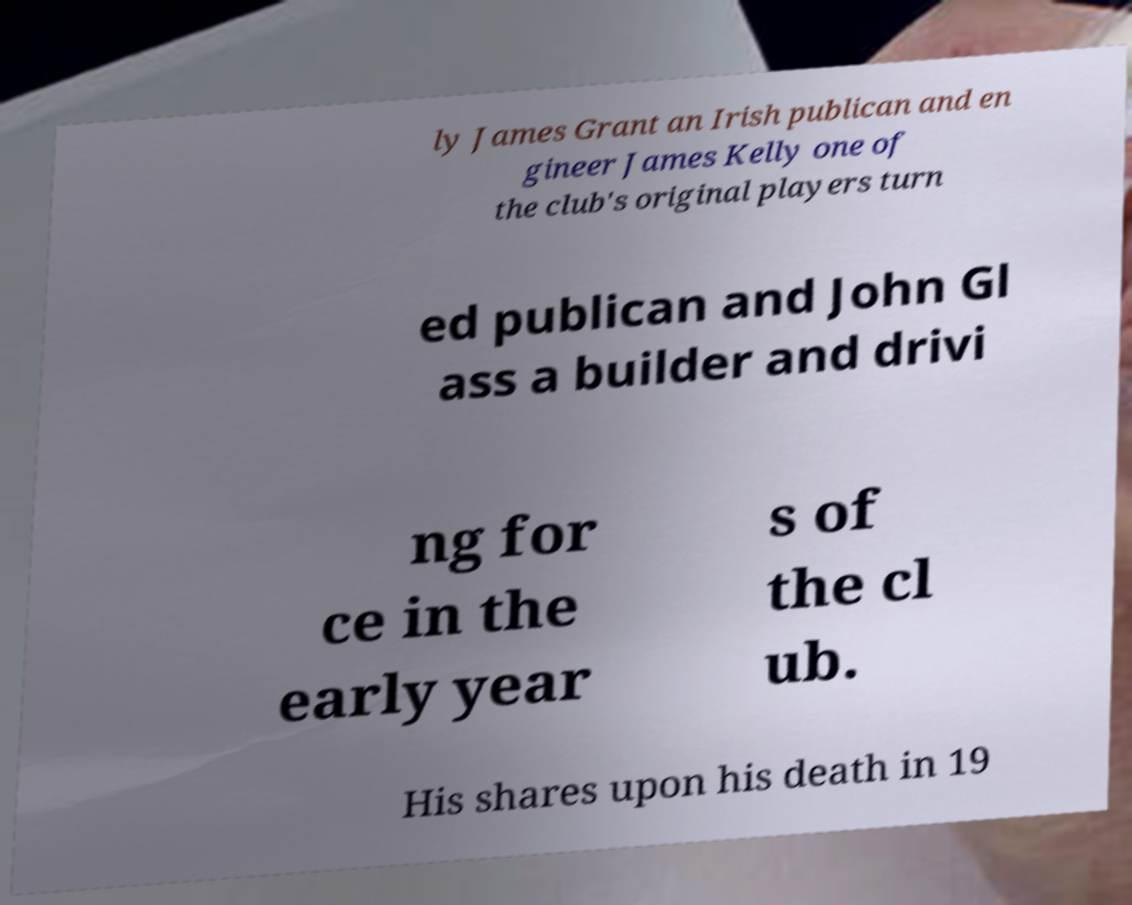Please read and relay the text visible in this image. What does it say? ly James Grant an Irish publican and en gineer James Kelly one of the club's original players turn ed publican and John Gl ass a builder and drivi ng for ce in the early year s of the cl ub. His shares upon his death in 19 